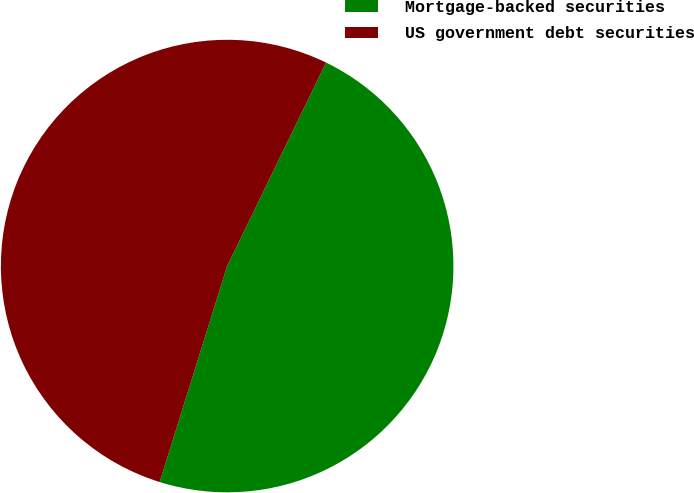Convert chart to OTSL. <chart><loc_0><loc_0><loc_500><loc_500><pie_chart><fcel>Mortgage-backed securities<fcel>US government debt securities<nl><fcel>47.62%<fcel>52.38%<nl></chart> 